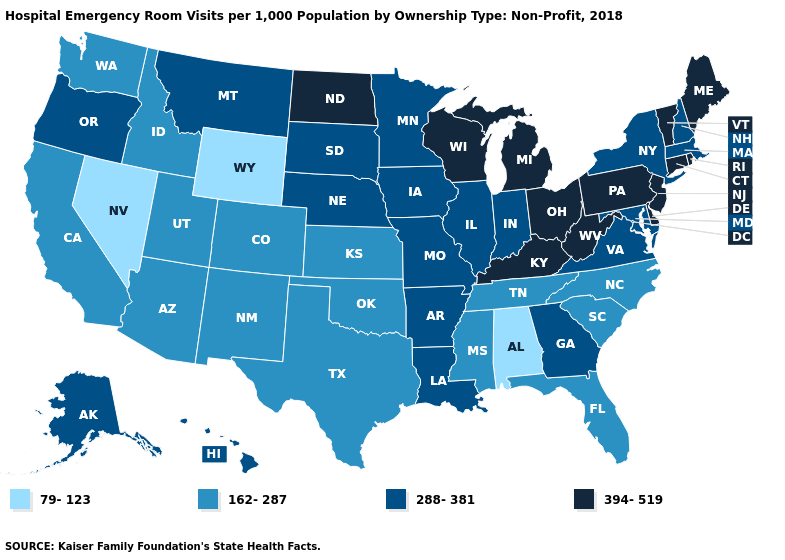What is the lowest value in states that border Missouri?
Quick response, please. 162-287. What is the lowest value in the USA?
Give a very brief answer. 79-123. Does Oregon have the highest value in the USA?
Give a very brief answer. No. Among the states that border Indiana , does Illinois have the highest value?
Quick response, please. No. What is the value of Vermont?
Be succinct. 394-519. Which states have the lowest value in the Northeast?
Write a very short answer. Massachusetts, New Hampshire, New York. What is the highest value in the West ?
Keep it brief. 288-381. Does Idaho have a lower value than Indiana?
Short answer required. Yes. Name the states that have a value in the range 394-519?
Write a very short answer. Connecticut, Delaware, Kentucky, Maine, Michigan, New Jersey, North Dakota, Ohio, Pennsylvania, Rhode Island, Vermont, West Virginia, Wisconsin. What is the lowest value in states that border Washington?
Keep it brief. 162-287. What is the value of Arkansas?
Be succinct. 288-381. Does the map have missing data?
Short answer required. No. What is the value of Missouri?
Keep it brief. 288-381. What is the highest value in the USA?
Write a very short answer. 394-519. Does New Mexico have a higher value than Florida?
Answer briefly. No. 